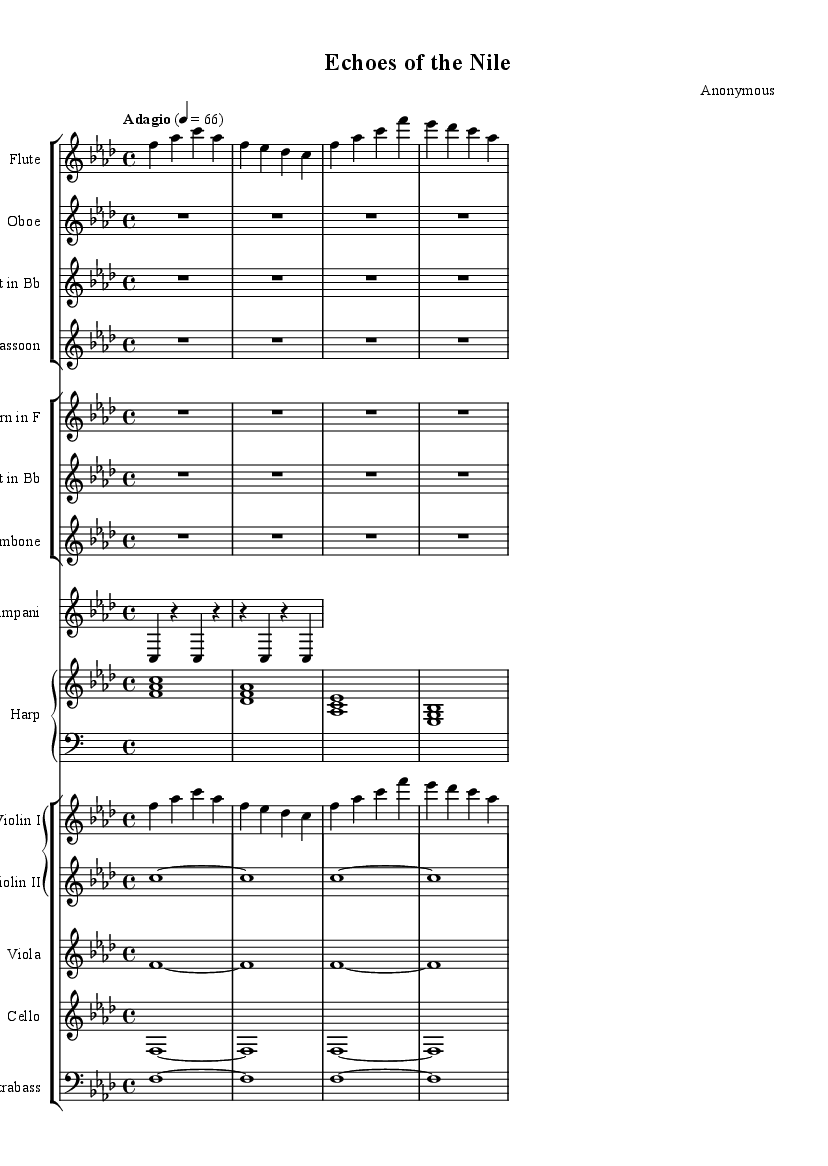What is the key signature of this music? The key signature is indicated at the beginning of the score and shows four flats, which corresponds to F minor.
Answer: F minor What is the time signature of this music? The time signature is located right after the key signature and shows a "4/4" notation, which means there are four beats per measure.
Answer: 4/4 What is the tempo marking for this piece? The tempo marking can be found at the beginning of the score, stating "Adagio" and indicating a metronome marking of 66 beats per minute, suggesting a slow pace.
Answer: Adagio Which woodwinds are present in this symphony? By observing the staff groups, we can identify the woodwinds: Flute, Oboe, Clarinet, and Bassoon are the instruments listed in the first group.
Answer: Flute, Oboe, Clarinet, Bassoon How many measures does the flute part contain? Examining the flute part, it is clear that there are four measures presented, each defined by the bar lines.
Answer: Four measures What is the rhythmic pattern of the Timpani in the first measure? The Timpani part shows a rhythmic pattern of one quarter note followed by two rests ending with another quarter note, which can be identified by looking at the note values and rests.
Answer: Quarter note, two rests, quarter note What musical form does this symphony likely follow? The structure of the music, typically based on thematic development and orchestration style, suggests a symphonic form characterized by distinct sections, but the specific form isn't provided in the sheet. However, it's reasonable to assume a standard form like sonata or theme and variations.
Answer: Likely sonata form 